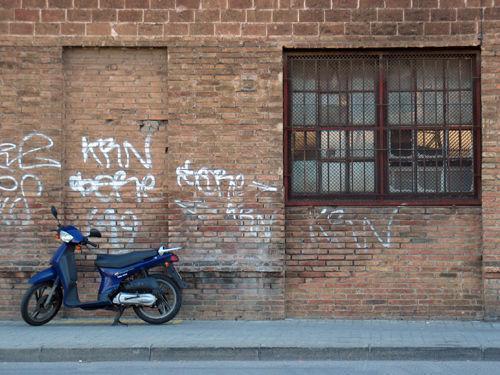How many headlights does the moped have?
Give a very brief answer. 1. How many tires does the moped have?
Give a very brief answer. 2. 